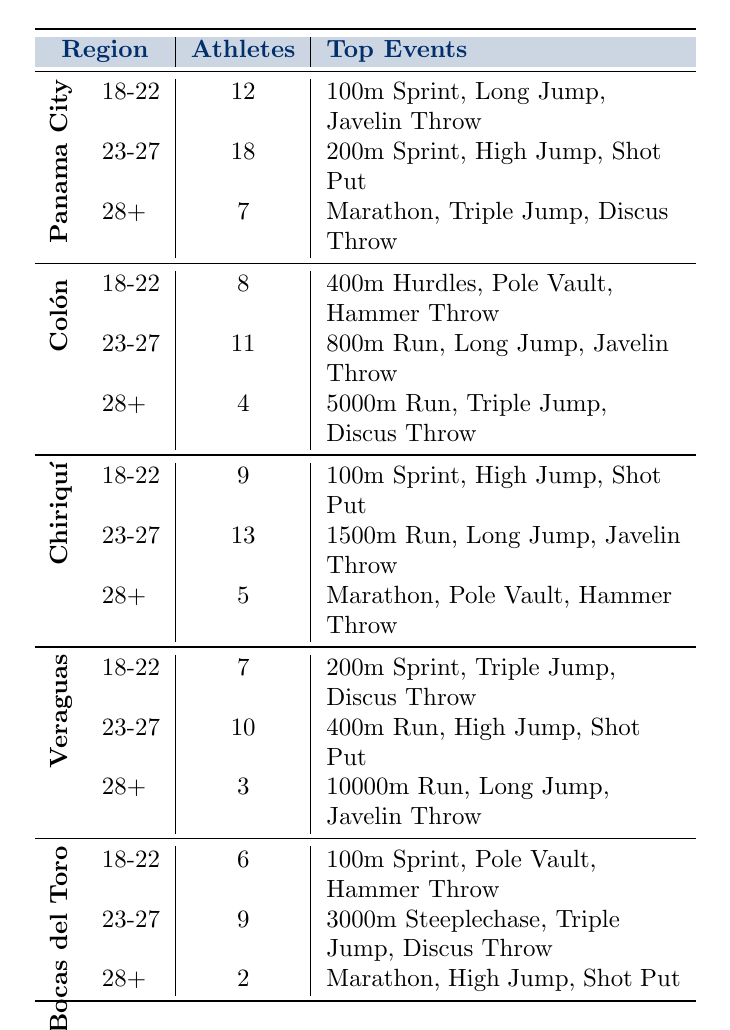What is the total number of athletes from Panama City? In Panama City, the athlete counts for the age groups are 12 (18-22), 18 (23-27), and 7 (28+). Summing these values gives 12 + 18 + 7 = 37.
Answer: 37 Which age group has the highest number of athletes in Colón? The athlete counts for Colón's age groups are 8 (18-22), 11 (23-27), and 4 (28+). The highest value is 11 in the 23-27 age group.
Answer: 23-27 How many athletes from Bocas del Toro are aged 28 and above? The athlete counts for Bocas del Toro aged 28 and above is 2.
Answer: 2 What are the top events for the 23-27 age group in Chiriquí? The top events listed for Chiriquí in the 23-27 age group are 1500m Run, Long Jump, and Javelin Throw.
Answer: 1500m Run, Long Jump, Javelin Throw Is there a region where the 18-22 age group has more athletes than the 23-27 age group? From the table, in Chiriquí, there are 9 athletes in the 18-22 age group compared to 13 in the 23-27 age group, and in Panama City, there are 12 compared to 18. In Colón, the counts are 8 and 11, respectively. So, no region shows the 18-22 age group exceeding the 23-27 age group.
Answer: No What is the average number of athletes for the age group 28+ across all regions? The counts of the age group 28+ are 7 (Panama City), 4 (Colón), 5 (Chiriquí), 3 (Veraguas), and 2 (Bocas del Toro). The total is 7 + 4 + 5 + 3 + 2 = 21. Dividing by the number of regions gives 21/5 = 4.2.
Answer: 4.2 Which region has the highest total count of athletes across all age groups? Summing the athlete counts for each region: Panama City = 37, Colón = 23, Chiriquí = 27, Veraguas = 20, and Bocas del Toro = 17. The highest total is from Panama City with 37.
Answer: Panama City What event is common to the 28+ age group in both Panama City and Chiriquí? The events listed for Panama City (28+) are Marathon, Triple Jump, and Discus Throw. For Chiriquí (28+), the events are Marathon, Pole Vault, and Hammer Throw. The common event is Marathon.
Answer: Marathon How many athletes participate in the 400m hurdles from Colón? In the table, the count of the 400m Hurdles for Colón's 18-22 age group is 8, and there are no other mentions of this event in other groups.
Answer: 8 Which age group in Veraguas has the least number of athletes? The athlete counts for Veraguas are 7 (18-22), 10 (23-27), and 3 (28+). The least count is 3 in the 28+ age group.
Answer: 28+ 